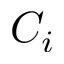Convert formula to latex. <formula><loc_0><loc_0><loc_500><loc_500>C _ { i }</formula> 